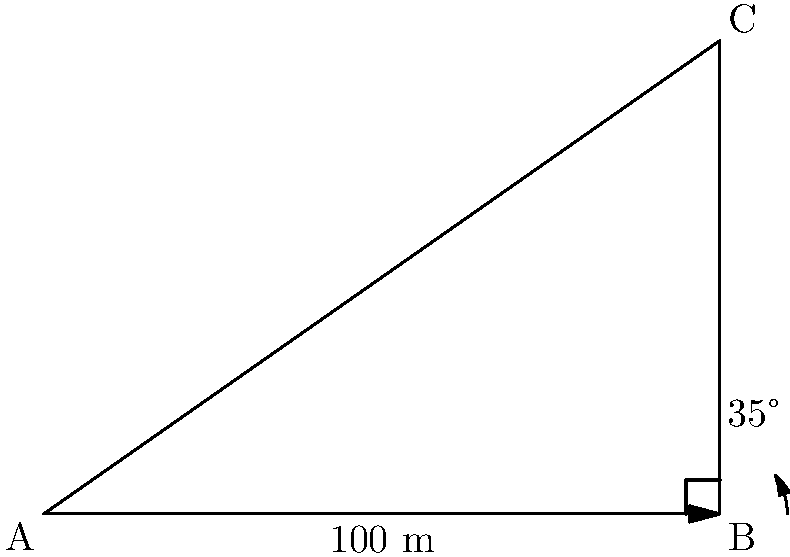As part of a construction project, you need to determine the height of a new skyscraper. Standing 100 meters away from the base of the building, you measure the angle of elevation to the top of the skyscraper to be 35°. Using this information, calculate the height of the skyscraper to the nearest meter. Let's approach this step-by-step:

1) We can model this scenario as a right-angled triangle, where:
   - The base of the triangle is the distance from where we're standing to the building (100 m)
   - The height of the triangle is the height of the building (what we're trying to find)
   - The angle between the base and the hypotenuse is the angle of elevation (35°)

2) In this right-angled triangle, we know:
   - The adjacent side (base) = 100 m
   - The angle = 35°
   - We need to find the opposite side (height)

3) This scenario calls for the use of the tangent trigonometric function:

   $\tan(\theta) = \frac{\text{opposite}}{\text{adjacent}}$

4) Plugging in our known values:

   $\tan(35°) = \frac{\text{height}}{100}$

5) To solve for the height, we multiply both sides by 100:

   $100 \cdot \tan(35°) = \text{height}$

6) Now we can calculate:
   
   $\text{height} = 100 \cdot \tan(35°) \approx 100 \cdot 0.7002 \approx 70.02$ meters

7) Rounding to the nearest meter as requested:

   $\text{height} \approx 70$ meters
Answer: 70 meters 